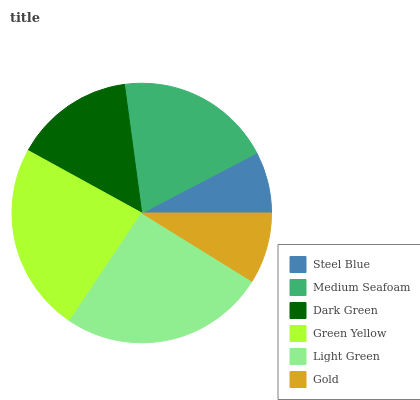Is Steel Blue the minimum?
Answer yes or no. Yes. Is Light Green the maximum?
Answer yes or no. Yes. Is Medium Seafoam the minimum?
Answer yes or no. No. Is Medium Seafoam the maximum?
Answer yes or no. No. Is Medium Seafoam greater than Steel Blue?
Answer yes or no. Yes. Is Steel Blue less than Medium Seafoam?
Answer yes or no. Yes. Is Steel Blue greater than Medium Seafoam?
Answer yes or no. No. Is Medium Seafoam less than Steel Blue?
Answer yes or no. No. Is Medium Seafoam the high median?
Answer yes or no. Yes. Is Dark Green the low median?
Answer yes or no. Yes. Is Light Green the high median?
Answer yes or no. No. Is Steel Blue the low median?
Answer yes or no. No. 